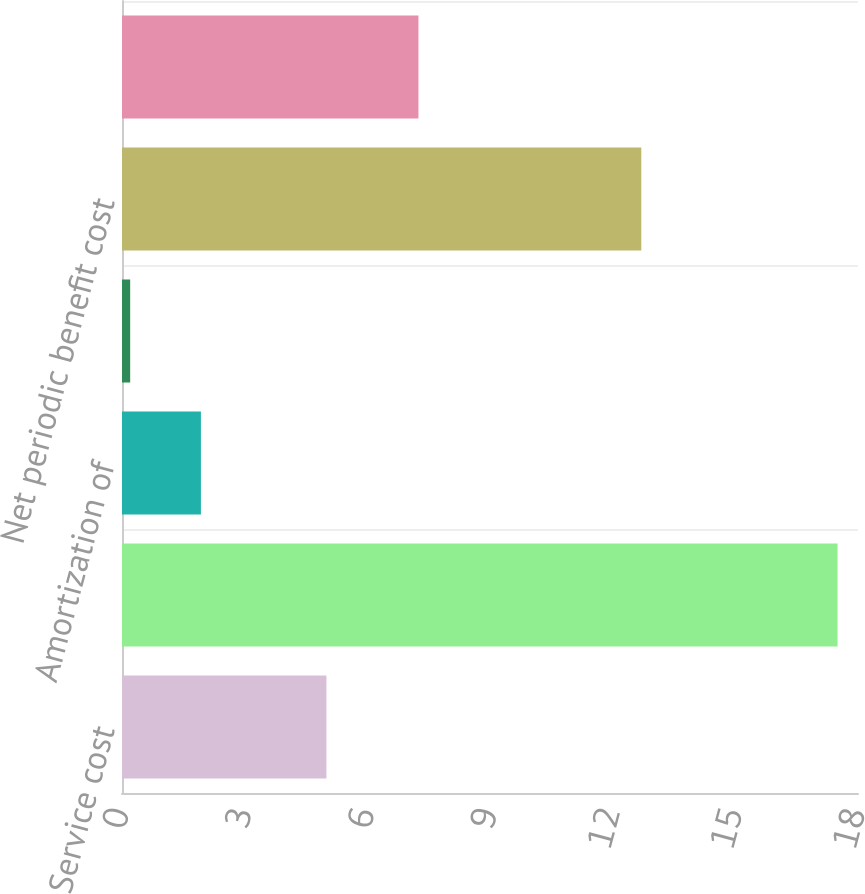Convert chart to OTSL. <chart><loc_0><loc_0><loc_500><loc_500><bar_chart><fcel>Service cost<fcel>Interest cost<fcel>Amortization of<fcel>Amortization of actuarial loss<fcel>Net periodic benefit cost<fcel>Discount rate<nl><fcel>5<fcel>17.5<fcel>1.93<fcel>0.2<fcel>12.7<fcel>7.25<nl></chart> 